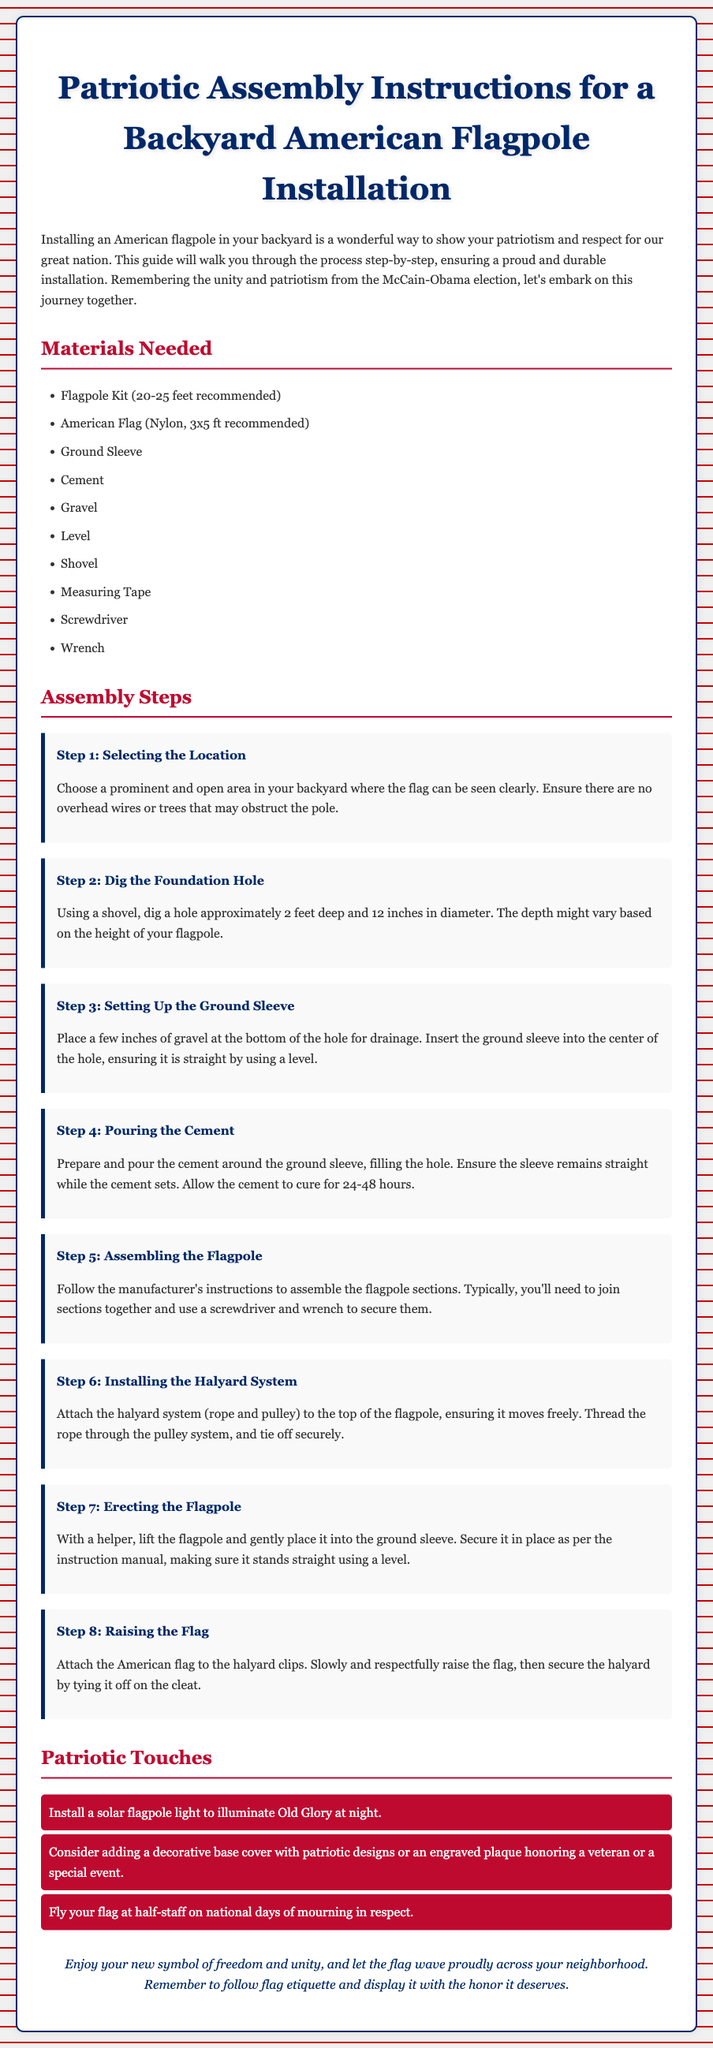What materials are needed? The materials needed are listed in the "Materials Needed" section, which includes items like a flagpole kit, American flag, ground sleeve, and more.
Answer: Flagpole kit, American flag, ground sleeve, cement, gravel, level, shovel, measuring tape, screwdriver, wrench What is the recommended flagpole height? The document specifies that a flagpole height of 20-25 feet is recommended.
Answer: 20-25 feet What should be the diameter of the foundation hole? The document states that the diameter of the foundation hole should be 12 inches.
Answer: 12 inches How deep should the foundation hole be? The depth of the foundation hole is mentioned as approximately 2 feet deep.
Answer: 2 feet What step involves pouring cement? The step that includes pouring cement is labeled as "Step 4: Pouring the Cement."
Answer: Step 4 What patriotic touch is suggested for the flagpole? The document mentions a solar flagpole light as a patriotic touch for illumination at night.
Answer: Solar flagpole light What is the purpose of using gravel at the bottom of the hole? The document indicates that gravel is used at the bottom of the hole for drainage.
Answer: Drainage Which step involves attaching the American flag? The step involving the attachment of the American flag is labeled "Step 8: Raising the Flag."
Answer: Step 8 